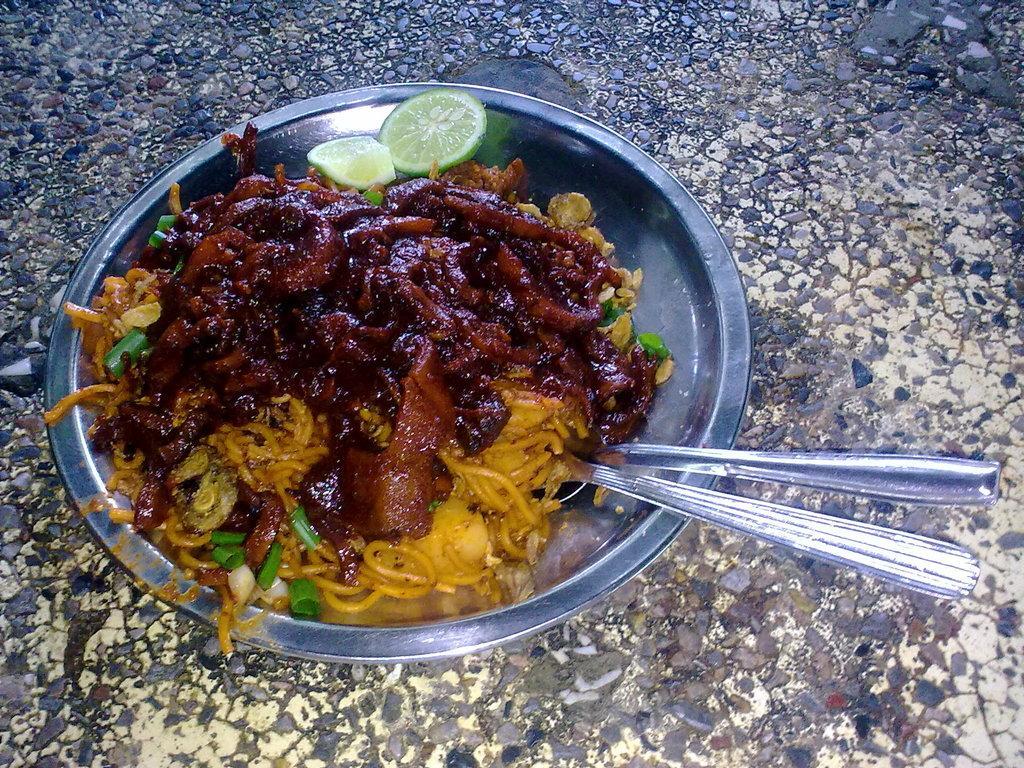Could you give a brief overview of what you see in this image? In this image we can see a plate with some food, pieces of lemon and spoons on the surface. 